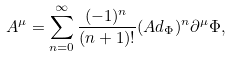<formula> <loc_0><loc_0><loc_500><loc_500>A ^ { \mu } = \sum _ { n = 0 } ^ { \infty } { \frac { ( - 1 ) ^ { n } } { ( n + 1 ) ! } ( A d _ { \Phi } ) ^ { n } \partial ^ { \mu } \Phi } ,</formula> 